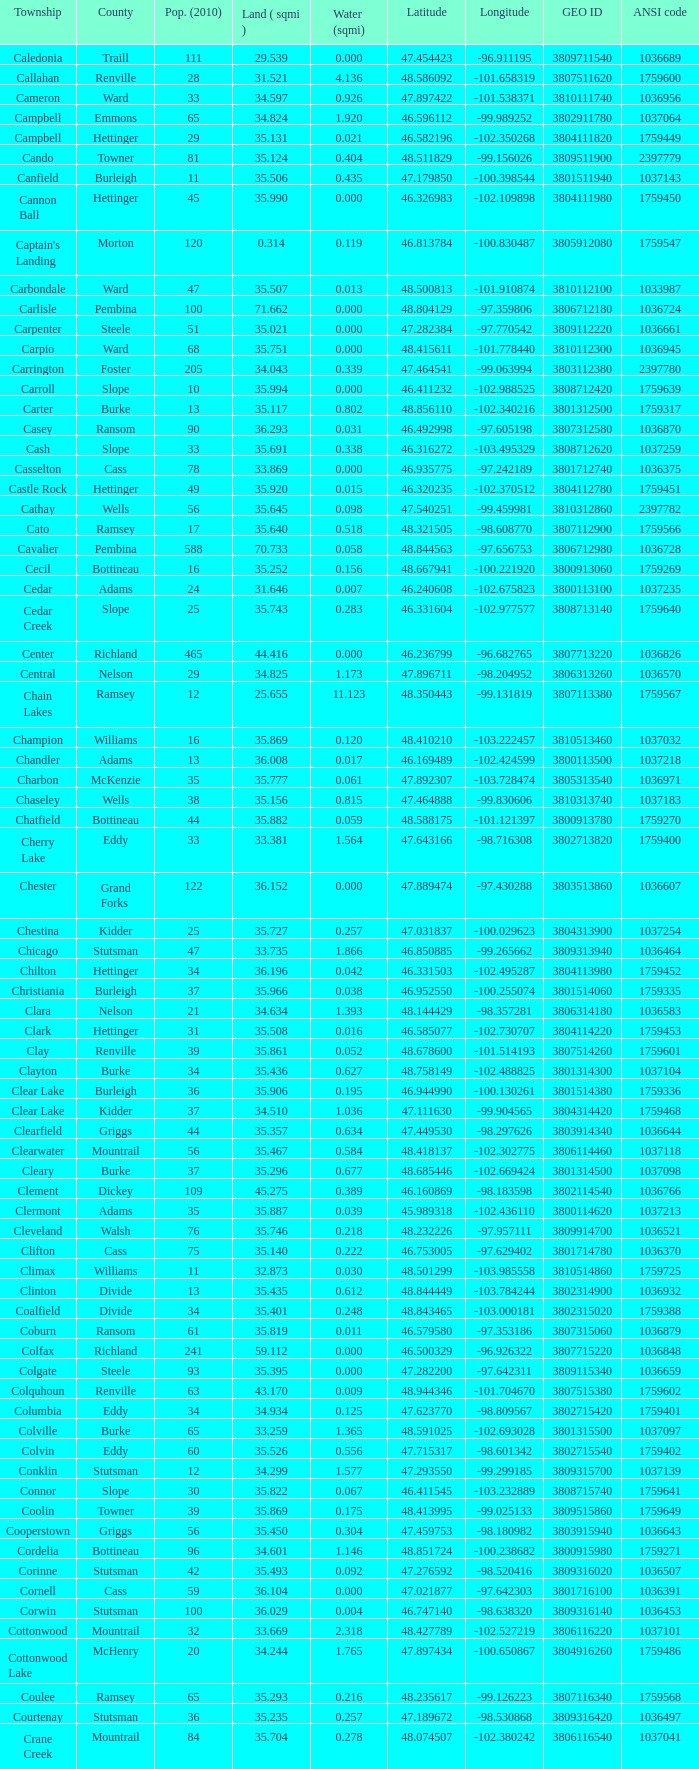What was the land area in sqmi that has a latitude of 48.763937? 35.898. 